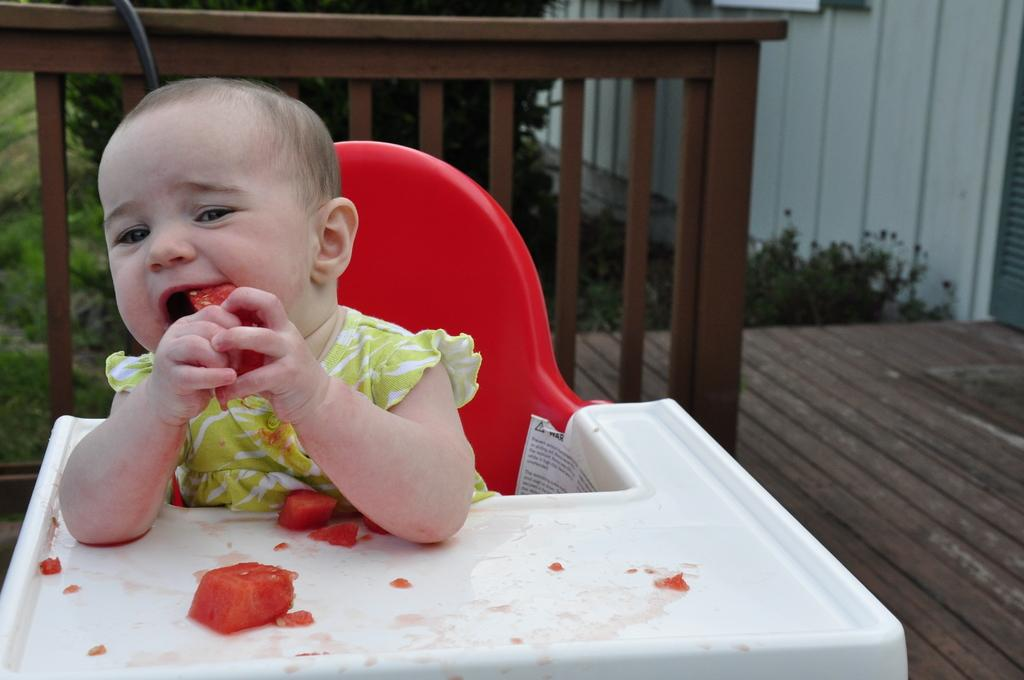What is the main subject of the image? There is a child in the image. What is the child sitting on? The child is sitting on a red color chair. What is the child doing while sitting on the chair? The child is eating food. What is the color of the food the child is eating? The food is red in color. What architectural feature can be seen in the image? There is a railing visible in the image. What can be seen in the background of the image? There are trees in the background of the image. What type of string is the child playing with in the image? There is no string present in the image. What is the child doing with the crate in the image? There is no crate present in the image. 